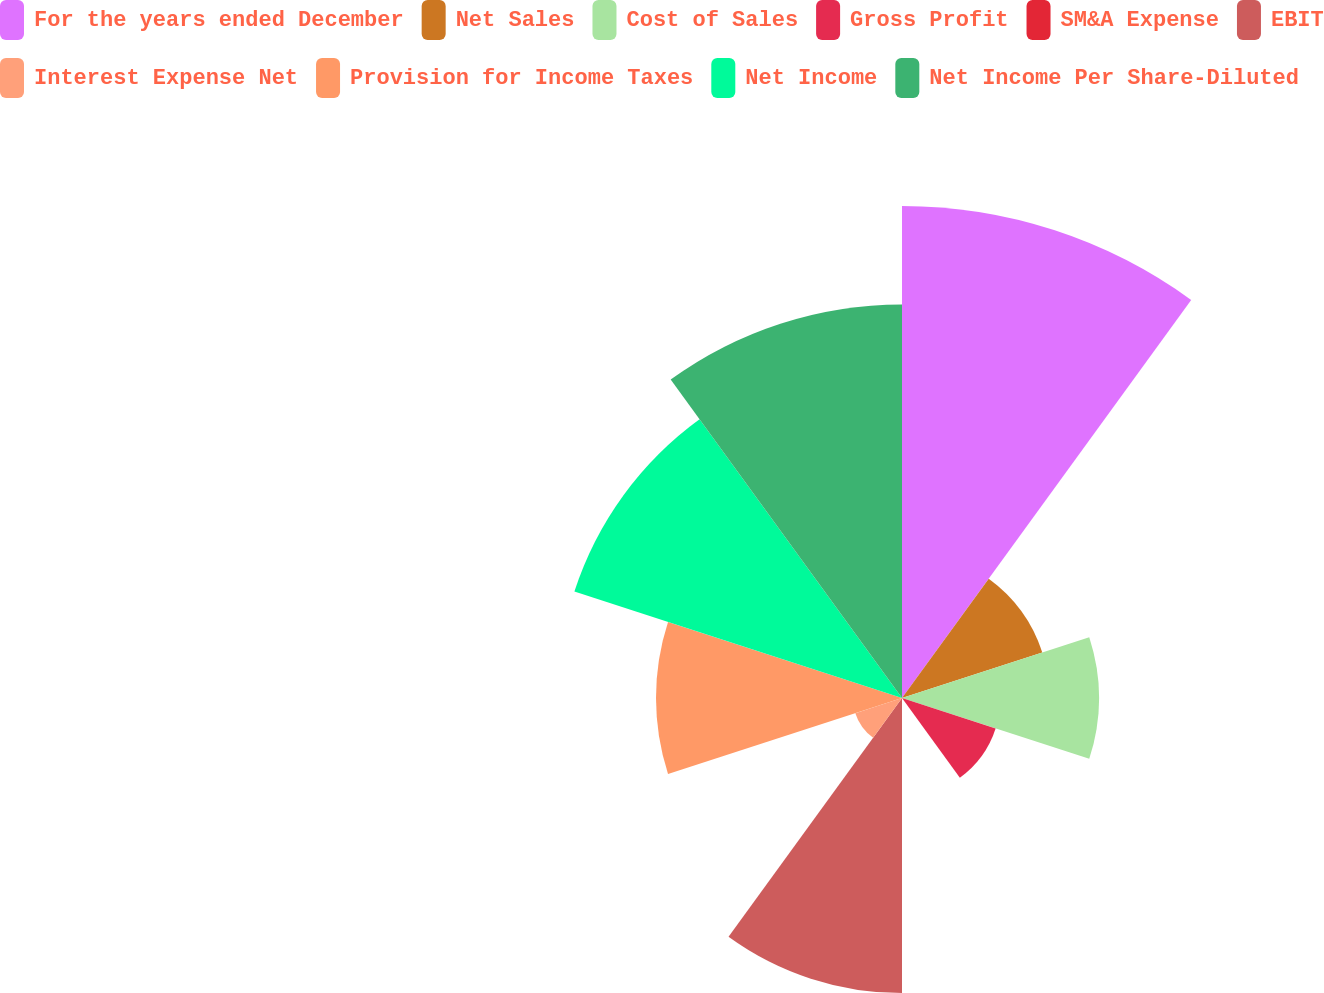Convert chart to OTSL. <chart><loc_0><loc_0><loc_500><loc_500><pie_chart><fcel>For the years ended December<fcel>Net Sales<fcel>Cost of Sales<fcel>Gross Profit<fcel>SM&A Expense<fcel>EBIT<fcel>Interest Expense Net<fcel>Provision for Income Taxes<fcel>Net Income<fcel>Net Income Per Share-Diluted<nl><fcel>21.74%<fcel>6.52%<fcel>8.7%<fcel>4.35%<fcel>0.0%<fcel>13.04%<fcel>2.17%<fcel>10.87%<fcel>15.22%<fcel>17.39%<nl></chart> 